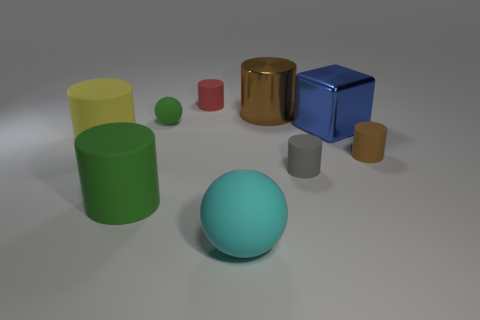Are there fewer tiny gray cylinders behind the large blue block than large cyan matte spheres in front of the big rubber sphere?
Your answer should be compact. No. There is a large ball that is the same material as the tiny red cylinder; what is its color?
Offer a terse response. Cyan. Is there a tiny green ball that is on the right side of the rubber thing that is behind the large brown metallic thing?
Keep it short and to the point. No. What is the color of the ball that is the same size as the gray object?
Your answer should be very brief. Green. What number of things are either red cylinders or matte things?
Your answer should be compact. 7. What size is the brown object that is in front of the brown thing that is behind the ball that is behind the large yellow cylinder?
Give a very brief answer. Small. How many small rubber spheres are the same color as the big metal cylinder?
Offer a terse response. 0. What number of cyan spheres have the same material as the small red thing?
Your response must be concise. 1. What number of objects are small matte objects or tiny objects that are on the right side of the small red thing?
Provide a short and direct response. 4. There is a tiny thing behind the big cylinder behind the ball that is behind the cyan thing; what is its color?
Keep it short and to the point. Red. 